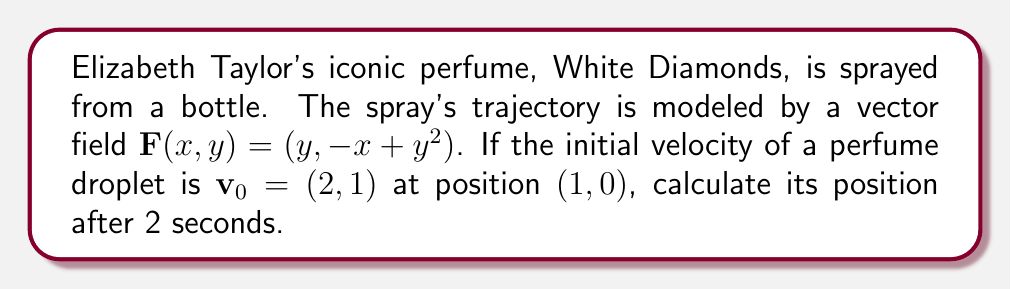Teach me how to tackle this problem. To solve this problem, we'll use the following steps:

1) The vector field $\mathbf{F}(x,y) = (y, -x + y^2)$ represents the acceleration of the perfume droplet at any point $(x,y)$.

2) We need to solve the system of differential equations:
   $$\frac{dx}{dt} = y$$
   $$\frac{dy}{dt} = -x + y^2$$

3) Given initial conditions: $x(0) = 1$, $y(0) = 0$, $\frac{dx}{dt}(0) = 2$, $\frac{dy}{dt}(0) = 1$

4) This system is nonlinear and difficult to solve analytically. We'll use Euler's method for numerical approximation:

   $$x_{n+1} = x_n + h \cdot \frac{dx}{dt}(t_n, x_n, y_n)$$
   $$y_{n+1} = y_n + h \cdot \frac{dy}{dt}(t_n, x_n, y_n)$$

   where $h$ is the time step. Let's use $h = 0.1$ for 20 steps to reach $t = 2$.

5) Starting values: $x_0 = 1$, $y_0 = 0$, $\frac{dx}{dt}_0 = 2$, $\frac{dy}{dt}_0 = 1$

6) For each step $n$ from 0 to 19:
   $$x_{n+1} = x_n + 0.1 \cdot \frac{dx}{dt}_n$$
   $$y_{n+1} = y_n + 0.1 \cdot \frac{dy}{dt}_n$$
   $$\frac{dx}{dt}_{n+1} = y_{n+1}$$
   $$\frac{dy}{dt}_{n+1} = -x_{n+1} + {y_{n+1}}^2$$

7) After 20 iterations, we get the approximate final position.
Answer: $(1.37, 3.22)$ 